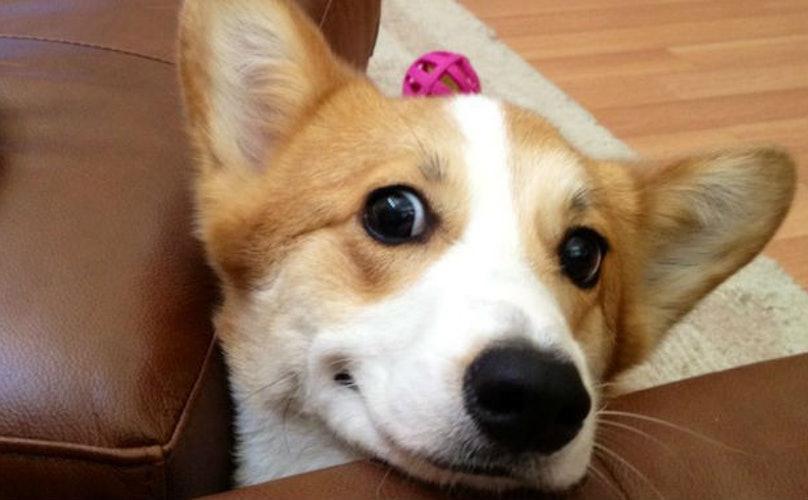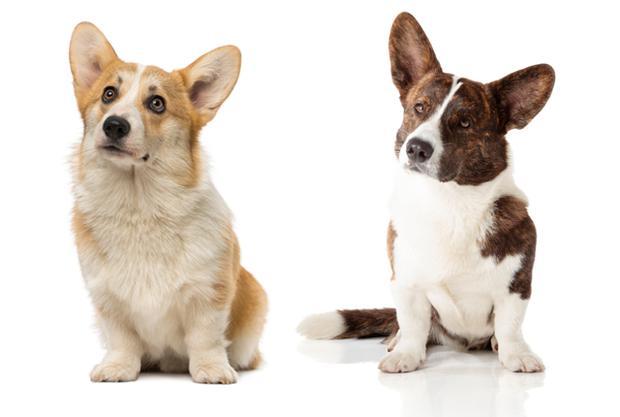The first image is the image on the left, the second image is the image on the right. Examine the images to the left and right. Is the description "Two corgies with similar tan coloring and ears standing up have smiling expressions and tongues hanging out." accurate? Answer yes or no. No. The first image is the image on the left, the second image is the image on the right. Examine the images to the left and right. Is the description "The right image includes a tan and white dog that is sitting upright on a white background." accurate? Answer yes or no. Yes. 